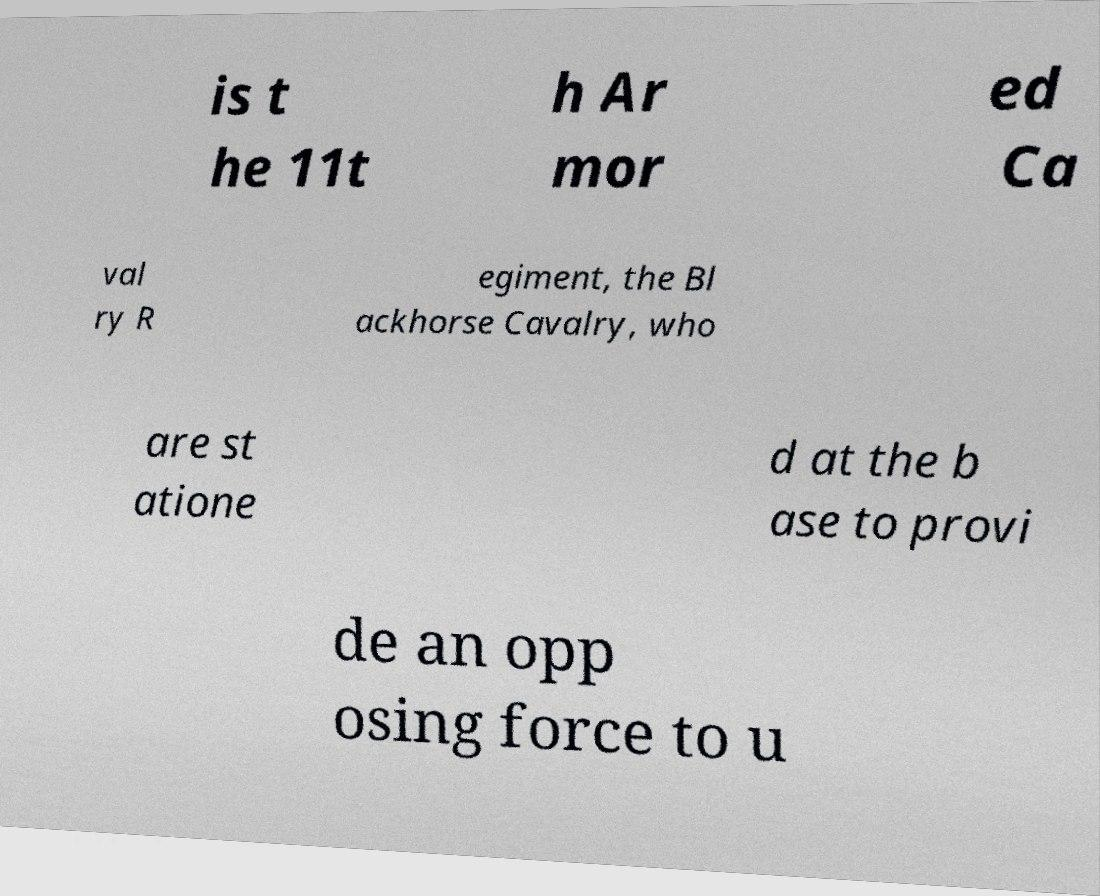For documentation purposes, I need the text within this image transcribed. Could you provide that? is t he 11t h Ar mor ed Ca val ry R egiment, the Bl ackhorse Cavalry, who are st atione d at the b ase to provi de an opp osing force to u 